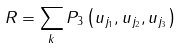Convert formula to latex. <formula><loc_0><loc_0><loc_500><loc_500>R = \sum _ { k } P _ { 3 } \left ( u _ { j _ { 1 } } , u _ { j _ { 2 } } , u _ { j _ { 3 } } \right ) \,</formula> 